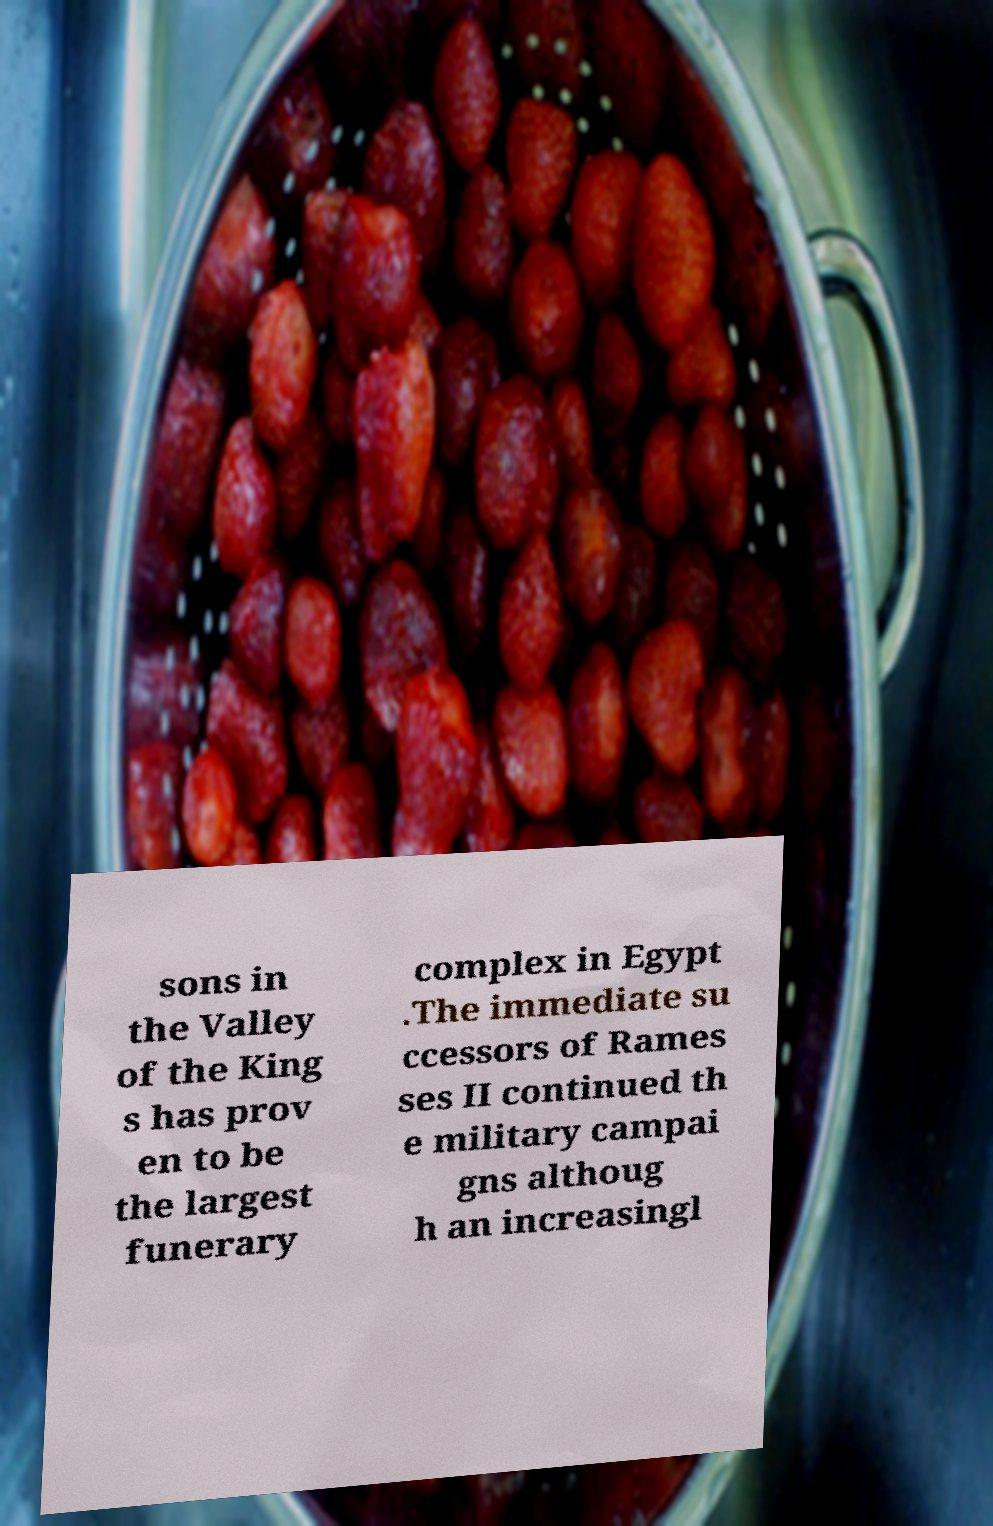There's text embedded in this image that I need extracted. Can you transcribe it verbatim? sons in the Valley of the King s has prov en to be the largest funerary complex in Egypt .The immediate su ccessors of Rames ses II continued th e military campai gns althoug h an increasingl 